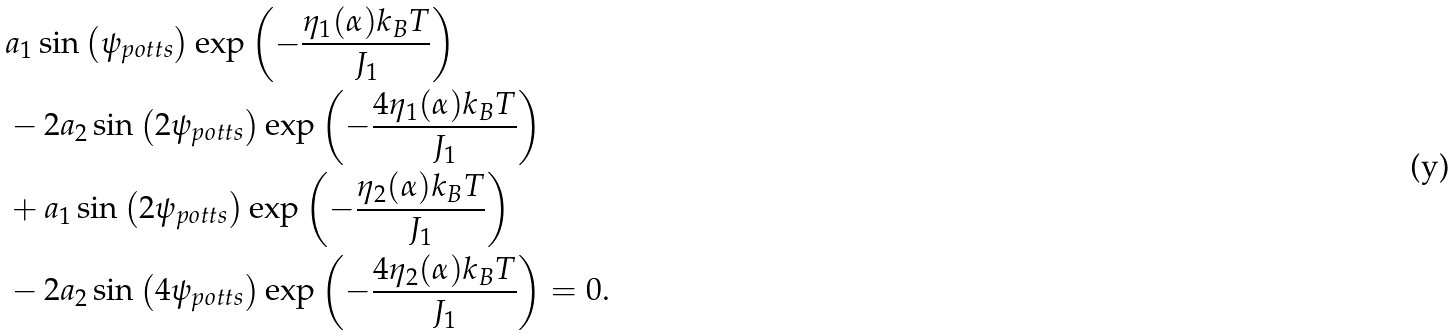Convert formula to latex. <formula><loc_0><loc_0><loc_500><loc_500>& a _ { 1 } \sin \left ( { \psi _ { p o t t s } } \right ) \exp \left ( { - \frac { \eta _ { 1 } ( \alpha ) k _ { B } T } { J _ { 1 } } } \right ) \\ & - 2 a _ { 2 } \sin \left ( { 2 \psi _ { p o t t s } } \right ) \exp \left ( { - \frac { 4 \eta _ { 1 } ( \alpha ) k _ { B } T } { J _ { 1 } } } \right ) \\ & + a _ { 1 } \sin \left ( { 2 \psi _ { p o t t s } } \right ) \exp \left ( { - \frac { \eta _ { 2 } ( \alpha ) k _ { B } T } { J _ { 1 } } } \right ) \\ & - 2 a _ { 2 } \sin \left ( { 4 \psi _ { p o t t s } } \right ) \exp \left ( { - \frac { 4 \eta _ { 2 } ( \alpha ) k _ { B } T } { J _ { 1 } } } \right ) = 0 .</formula> 